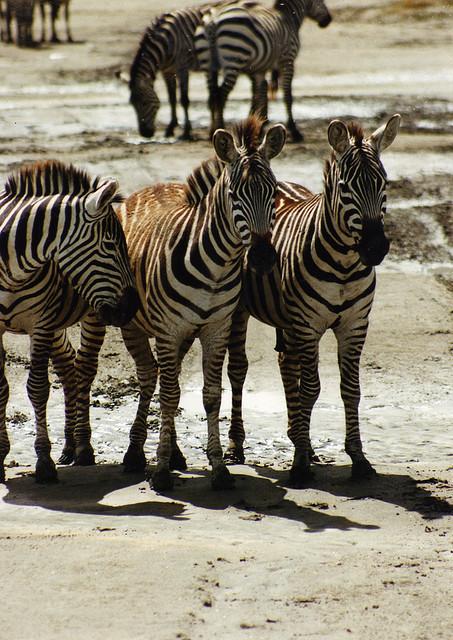How many zebras are there?
Be succinct. 5. How many tails can you see?
Short answer required. 1. How many zebras are facing the camera?
Write a very short answer. 2. 